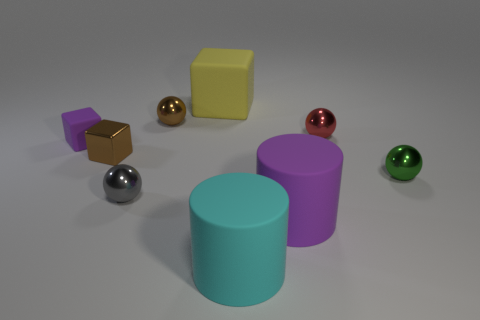There is a shiny block; is its color the same as the sphere that is behind the red ball?
Keep it short and to the point. Yes. Are there more tiny things to the right of the small metallic cube than red metal balls in front of the large yellow matte thing?
Make the answer very short. Yes. What is the shape of the tiny purple thing that is the same material as the big purple thing?
Offer a terse response. Cube. How many other things are there of the same shape as the yellow object?
Provide a succinct answer. 2. What shape is the purple rubber object that is on the left side of the big cyan object?
Provide a succinct answer. Cube. The small rubber thing is what color?
Ensure brevity in your answer.  Purple. How many other objects are there of the same size as the gray metal sphere?
Ensure brevity in your answer.  5. The small block that is in front of the purple matte object left of the gray sphere is made of what material?
Your answer should be very brief. Metal. Do the cyan object and the matte object behind the tiny red metallic ball have the same size?
Offer a terse response. Yes. Is there a big rubber thing of the same color as the tiny metal cube?
Offer a terse response. No. 